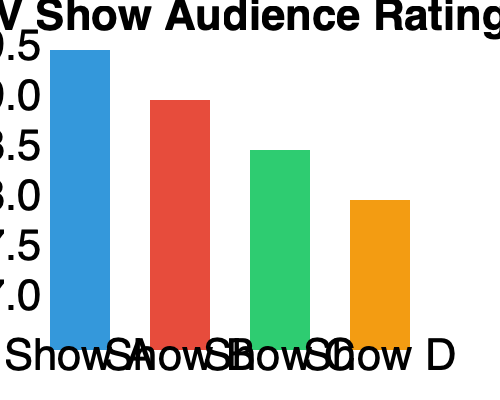As a movie club organizer, you're analyzing audience ratings for potential TV shows to discuss. Based on the bar chart showing audience ratings for four TV shows, what is the difference in ratings between the highest-rated and lowest-rated shows? To find the difference between the highest and lowest-rated shows, we need to:

1. Identify the highest-rated show:
   Show A has the tallest bar, corresponding to a rating of 9.5.

2. Identify the lowest-rated show:
   Show D has the shortest bar, corresponding to a rating of 8.0.

3. Calculate the difference:
   $9.5 - 8.0 = 1.5$

Therefore, the difference in ratings between the highest-rated and lowest-rated shows is 1.5 points.
Answer: 1.5 